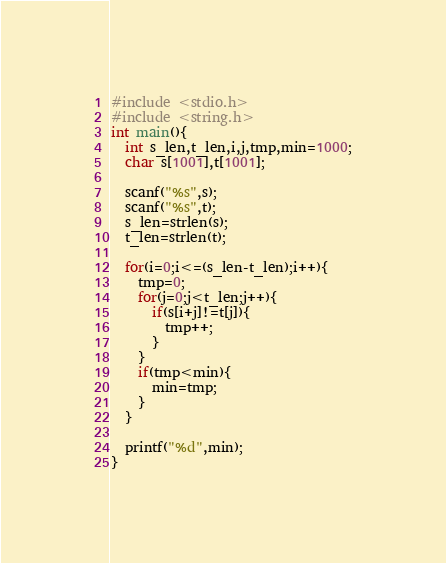Convert code to text. <code><loc_0><loc_0><loc_500><loc_500><_C_>#include <stdio.h>
#include <string.h>
int main(){
  int s_len,t_len,i,j,tmp,min=1000;
  char s[1001],t[1001];
  
  scanf("%s",s);
  scanf("%s",t);
  s_len=strlen(s);
  t_len=strlen(t);
  
  for(i=0;i<=(s_len-t_len);i++){
    tmp=0;
    for(j=0;j<t_len;j++){
      if(s[i+j]!=t[j]){
        tmp++;
      }
    }
    if(tmp<min){
      min=tmp;
    }
  }
  
  printf("%d",min);
}
</code> 